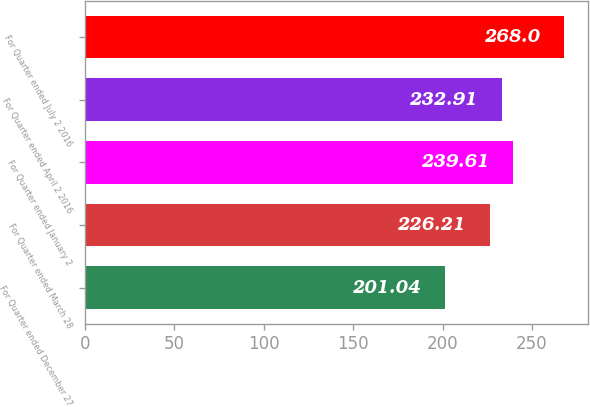Convert chart. <chart><loc_0><loc_0><loc_500><loc_500><bar_chart><fcel>For Quarter ended December 27<fcel>For Quarter ended March 28<fcel>For Quarter ended January 2<fcel>For Quarter ended April 2 2016<fcel>For Quarter ended July 2 2016<nl><fcel>201.04<fcel>226.21<fcel>239.61<fcel>232.91<fcel>268<nl></chart> 